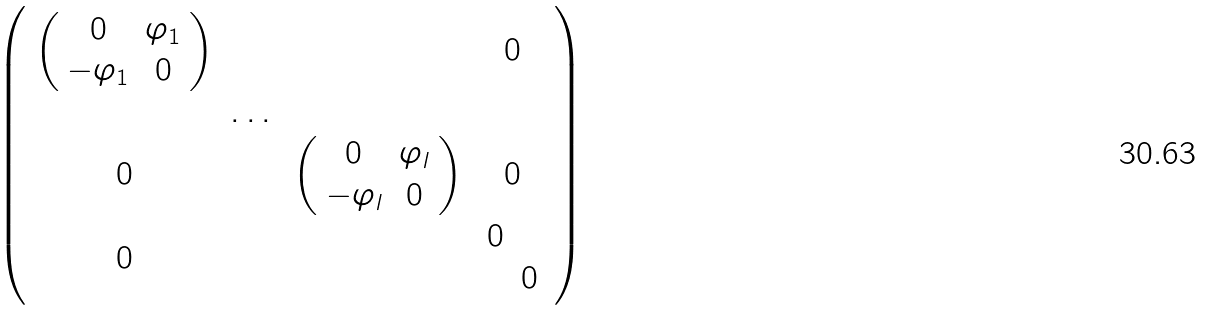<formula> <loc_0><loc_0><loc_500><loc_500>\left ( \begin{array} { c c c c c c } \left ( \begin{array} { c c } 0 & \varphi _ { 1 } \\ - \varphi _ { 1 } & 0 \\ \end{array} \right ) & & & 0 \\ & \dots & \\ 0 & & \left ( \begin{array} { c c } 0 & \varphi _ { l } \\ - \varphi _ { l } & 0 \\ \end{array} \right ) & 0 \\ 0 & & & \begin{array} { c c } 0 & \\ & 0 \\ \end{array} \\ \end{array} \right )</formula> 